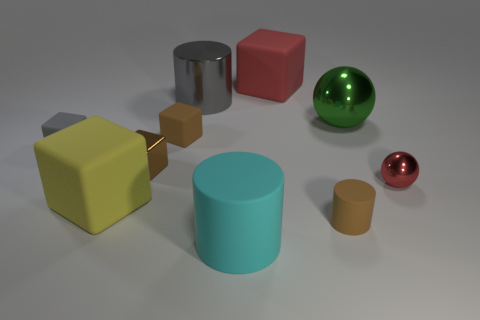Is the material of the large cylinder behind the small brown matte cylinder the same as the cylinder to the right of the cyan cylinder?
Provide a succinct answer. No. Is the number of metallic things that are to the right of the big ball greater than the number of tiny matte cylinders?
Provide a succinct answer. No. There is a big shiny object that is left of the tiny rubber object to the right of the cyan rubber thing; what color is it?
Your response must be concise. Gray. The green metallic thing that is the same size as the cyan object is what shape?
Make the answer very short. Sphere. What shape is the small object that is the same color as the metallic cylinder?
Offer a terse response. Cube. Is the number of yellow rubber things right of the small brown metal block the same as the number of big red matte objects?
Give a very brief answer. No. What material is the large sphere behind the ball that is in front of the brown matte thing that is to the left of the cyan matte cylinder?
Offer a very short reply. Metal. There is a large gray thing that is the same material as the big green ball; what shape is it?
Your answer should be compact. Cylinder. Is there any other thing that has the same color as the big metallic sphere?
Your response must be concise. No. What number of brown matte objects are in front of the thing in front of the brown matte thing in front of the big yellow rubber thing?
Your answer should be compact. 0. 